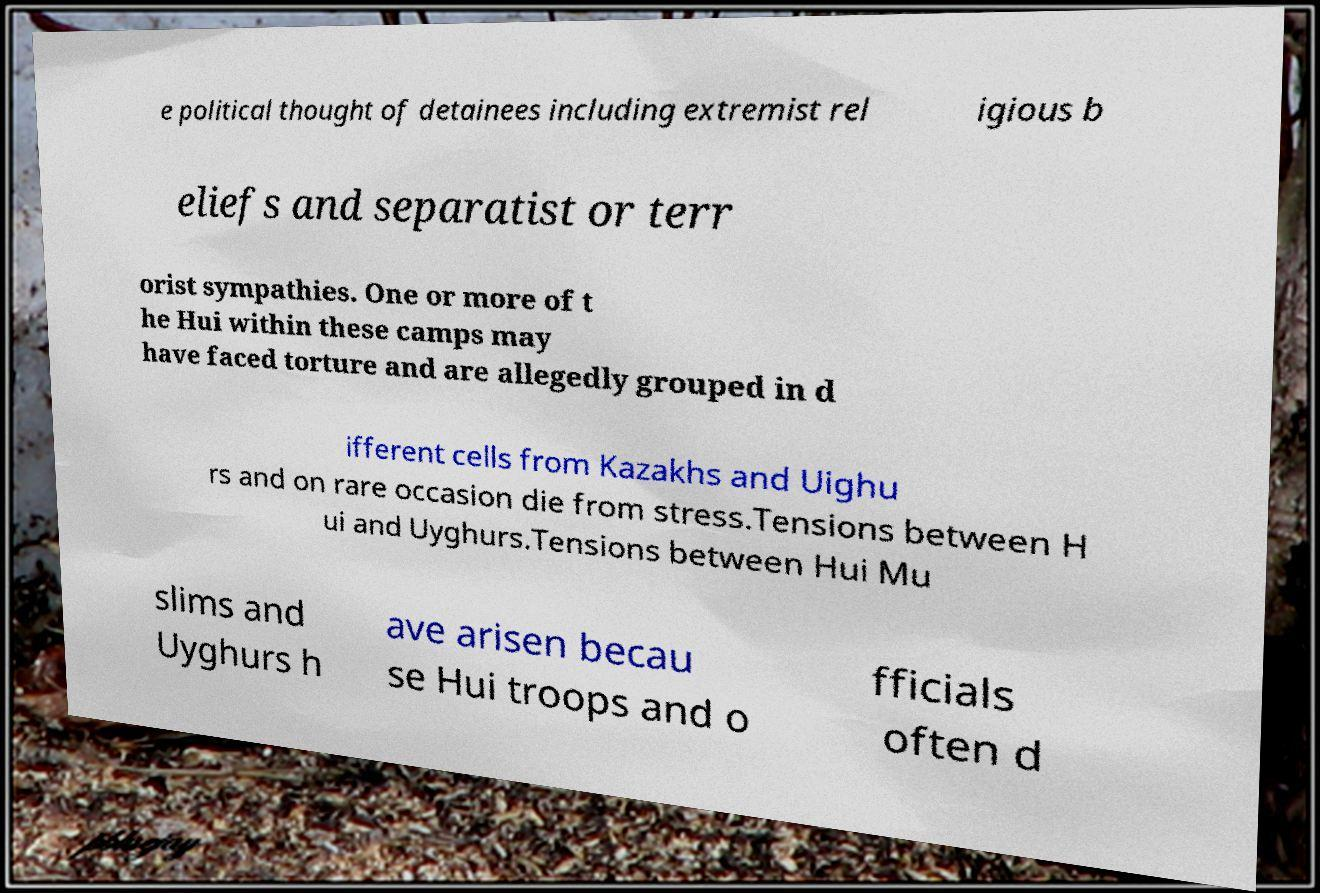Can you read and provide the text displayed in the image?This photo seems to have some interesting text. Can you extract and type it out for me? e political thought of detainees including extremist rel igious b eliefs and separatist or terr orist sympathies. One or more of t he Hui within these camps may have faced torture and are allegedly grouped in d ifferent cells from Kazakhs and Uighu rs and on rare occasion die from stress.Tensions between H ui and Uyghurs.Tensions between Hui Mu slims and Uyghurs h ave arisen becau se Hui troops and o fficials often d 